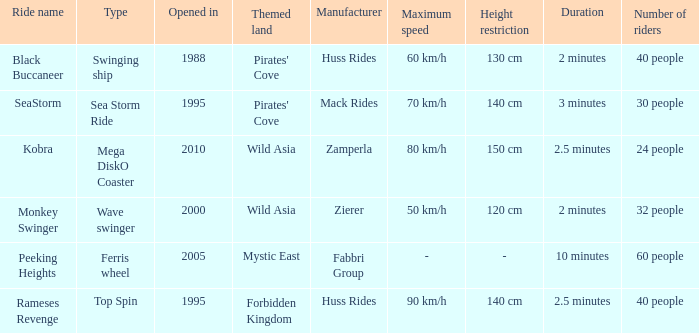Which ride opened after the 2000 Peeking Heights? Ferris wheel. 